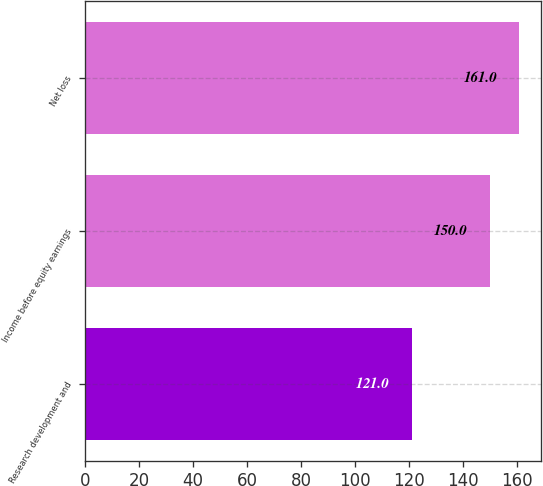Convert chart to OTSL. <chart><loc_0><loc_0><loc_500><loc_500><bar_chart><fcel>Research development and<fcel>Income before equity earnings<fcel>Net loss<nl><fcel>121<fcel>150<fcel>161<nl></chart> 